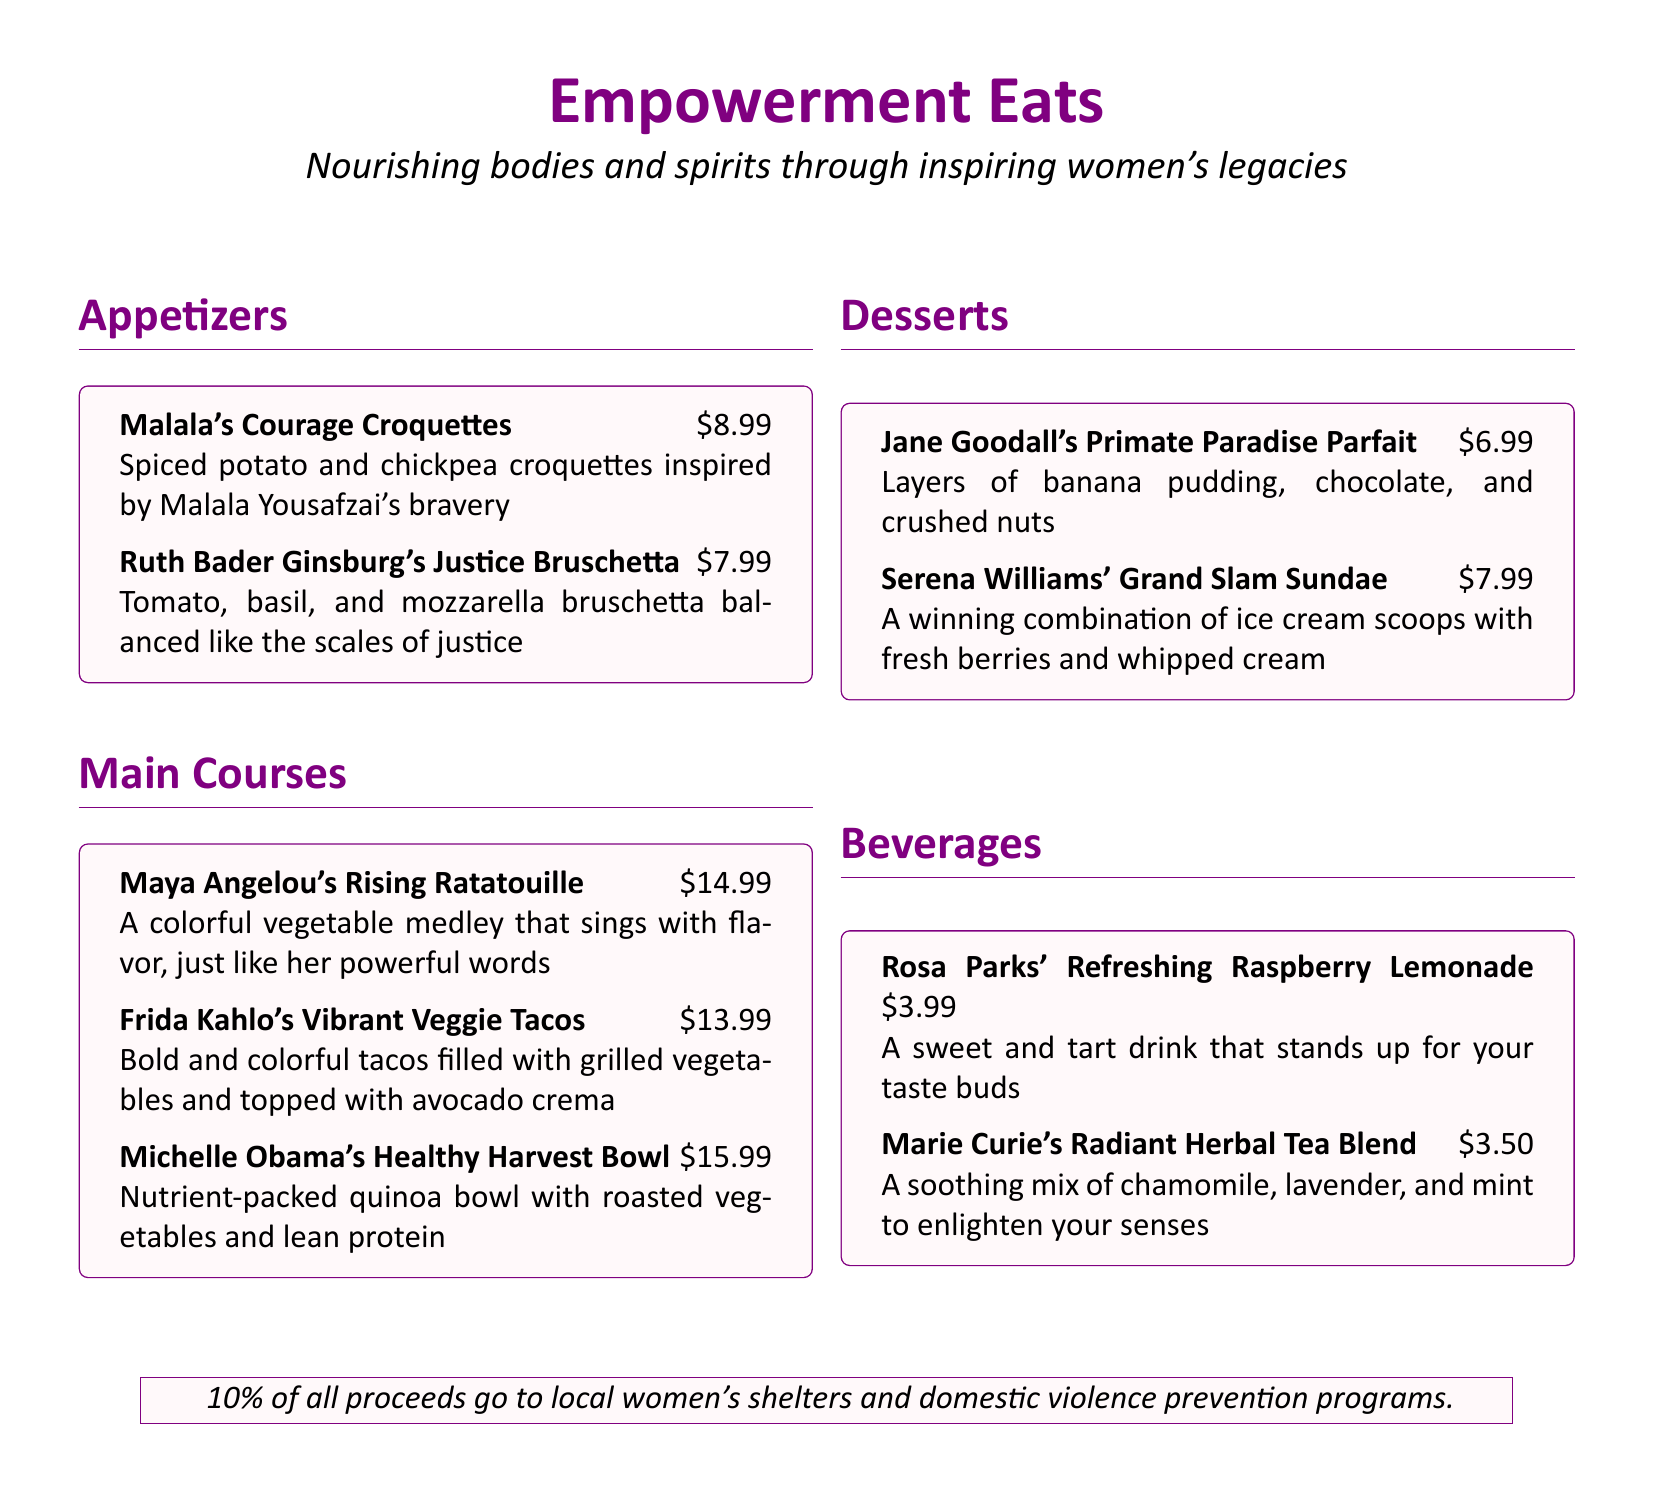What is the price of Malala's Courage Croquettes? The price is listed next to the dish name in the menu.
Answer: $8.99 What main course is named after Michelle Obama? The question asks for a specific dish from the main courses section of the menu.
Answer: Michelle Obama's Healthy Harvest Bowl How much does Rosa Parks' Refreshing Raspberry Lemonade cost? The cost is specified after the drink name in the beverages section.
Answer: $3.99 Which dessert features layers of banana pudding? The question relates to identifying a specific dessert from the desserts section.
Answer: Jane Goodall's Primate Paradise Parfait What percentage of proceeds is donated to women's shelters? The document states the percentage at the end.
Answer: 10% Which activist inspired the Grand Slam Sundae? This requires a connection between the dessert and its inspirational figure.
Answer: Serena Williams What type of dish is Maya Angelou's Rising Ratatouille? The question is about the category of the dish mentioned in the menu.
Answer: Main Course Which beverage is made with chamomile? This requires identifying a specific drink from the menu that contains chamomile.
Answer: Marie Curie's Radiant Herbal Tea Blend 